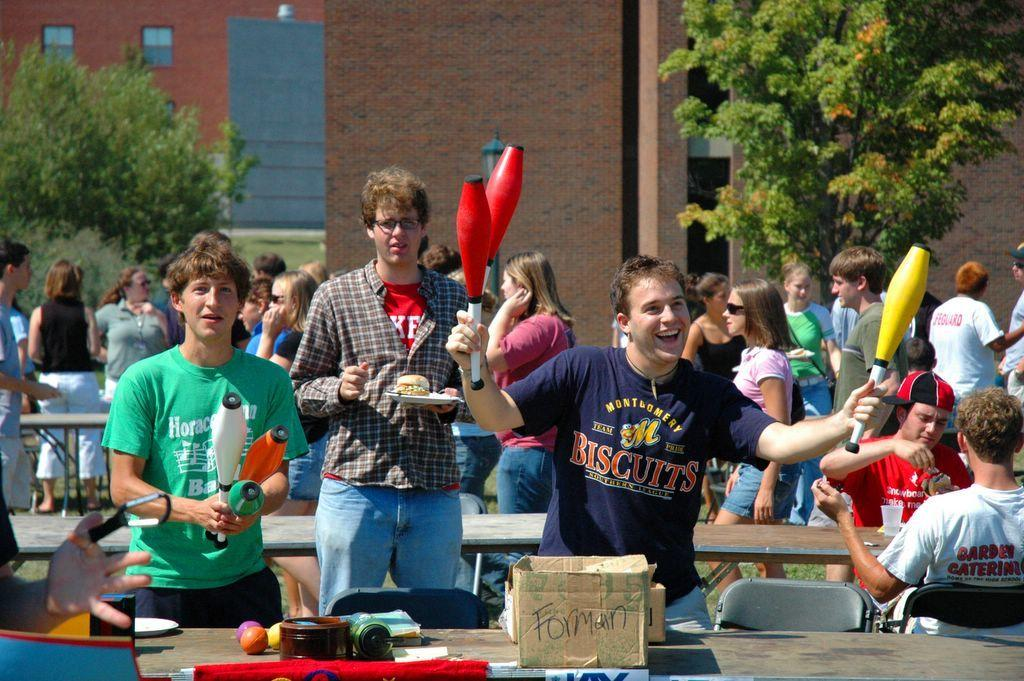<image>
Offer a succinct explanation of the picture presented. A man wearing a Montgomery Biscuits blue tee shirt is smiling while holding juggling pins in both hands. 